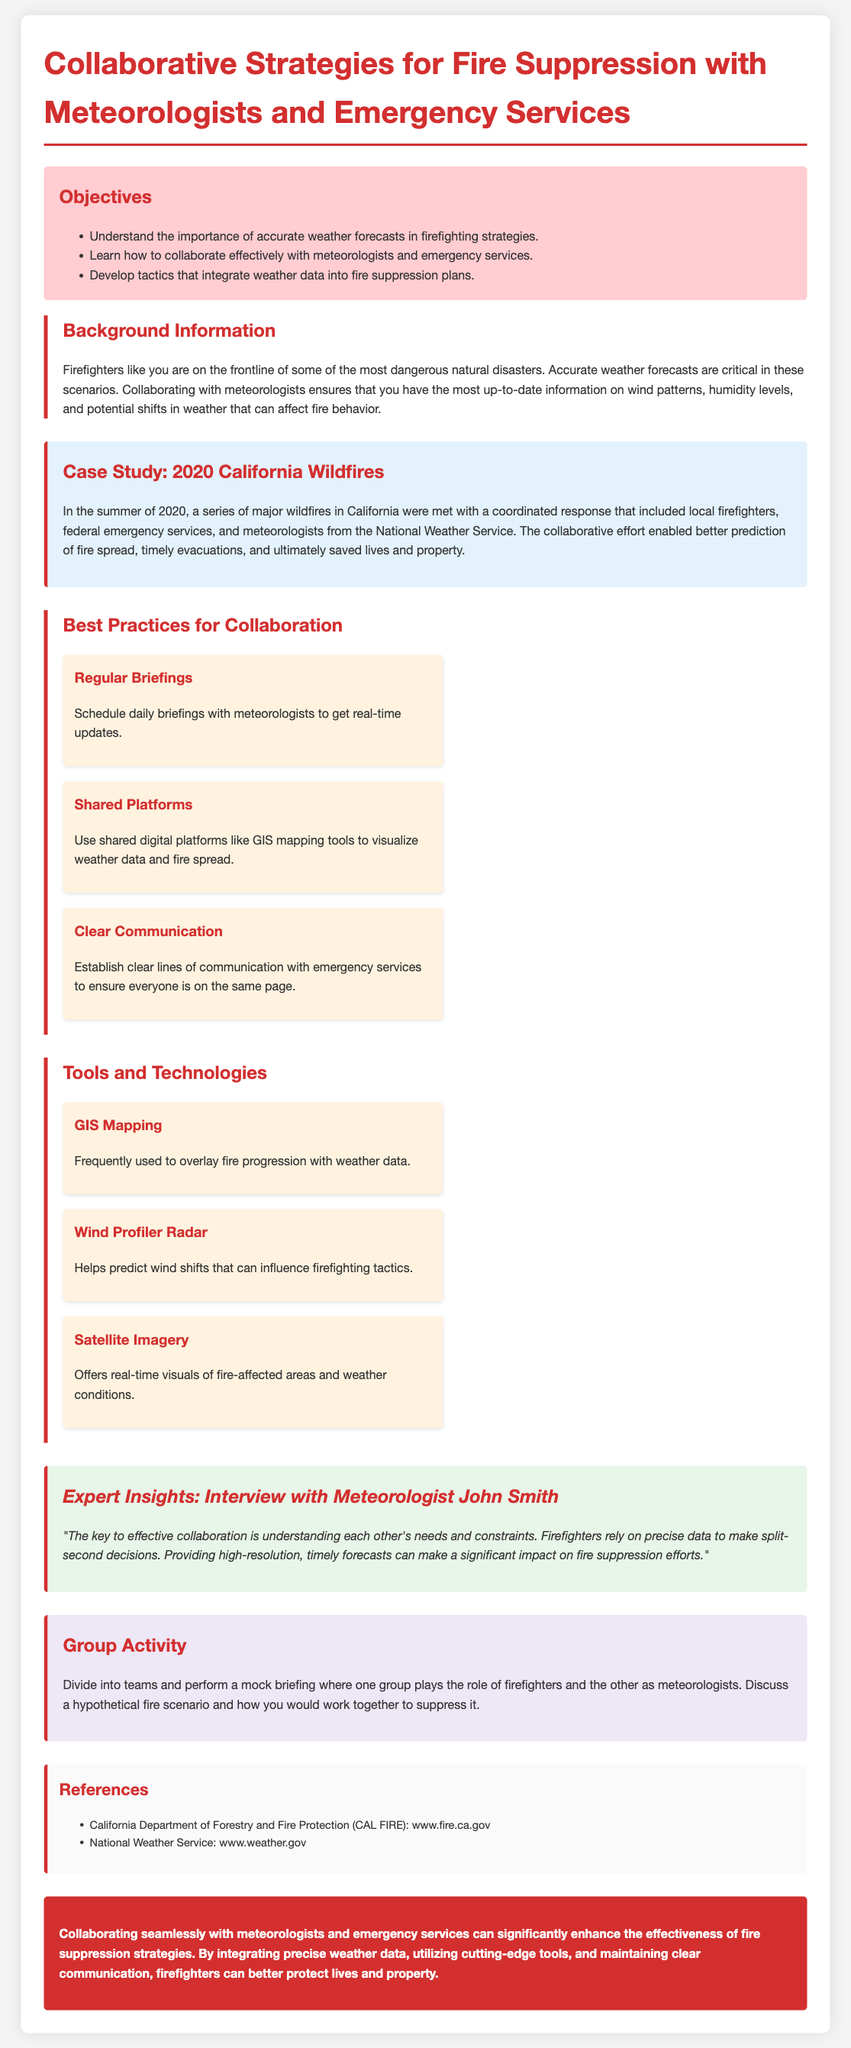What is the title of the lesson plan? The title of the lesson plan is the main heading of the document, which outlines the focus of the content.
Answer: Collaborative Strategies for Fire Suppression with Meteorologists and Emergency Services What is one objective of the lesson plan? The objectives are listed in a bullet format, highlighting the main goals of the lesson.
Answer: Understand the importance of accurate weather forecasts in firefighting strategies What case study is mentioned in the document? The case study is provided to illustrate real-world collaborative strategies during significant wildfires.
Answer: 2020 California Wildfires What tool helps predict wind shifts? The tools section details specific technologies that aid firefighting efforts, naming specific tools related to wind prediction.
Answer: Wind Profiler Radar Who is interviewed in the expert insights section? The expert insights provide quotes from a specific individual recognized for their expertise in the relevant area.
Answer: Meteorologist John Smith How many best practices for collaboration are listed? The best practices section lists methods for improving collaboration, which can be easily counted.
Answer: Three What color is used for the conclusion background? The conclusion section features a distinct formatting choice, including the background color, to emphasize the closing message.
Answer: Red 